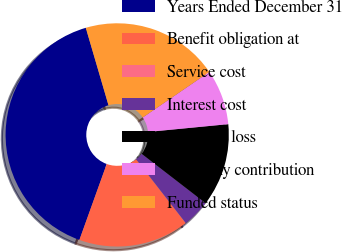<chart> <loc_0><loc_0><loc_500><loc_500><pie_chart><fcel>Years Ended December 31<fcel>Benefit obligation at<fcel>Service cost<fcel>Interest cost<fcel>Actuarial loss<fcel>Company contribution<fcel>Funded status<nl><fcel>39.96%<fcel>16.0%<fcel>0.02%<fcel>4.01%<fcel>12.0%<fcel>8.01%<fcel>19.99%<nl></chart> 